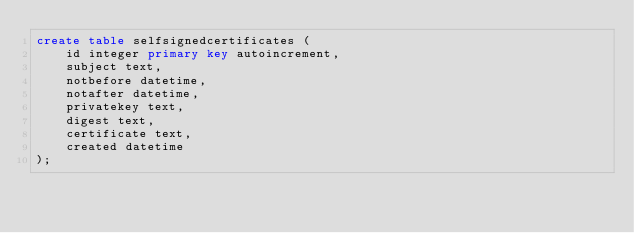Convert code to text. <code><loc_0><loc_0><loc_500><loc_500><_SQL_>create table selfsignedcertificates (
	id integer primary key autoincrement,
	subject text,
	notbefore datetime,
	notafter datetime,
	privatekey text,
	digest text,
	certificate text,
	created datetime
);

</code> 